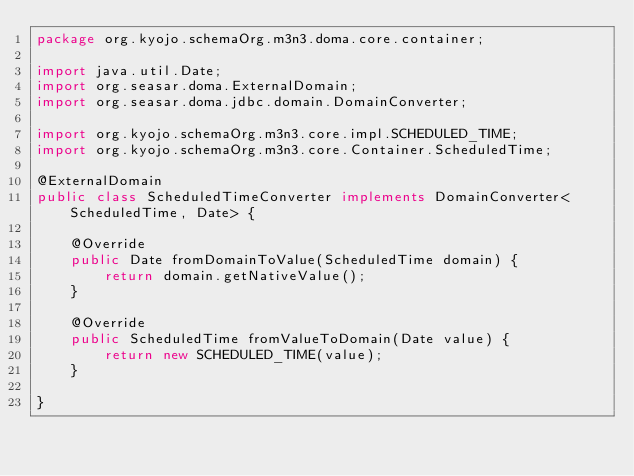Convert code to text. <code><loc_0><loc_0><loc_500><loc_500><_Java_>package org.kyojo.schemaOrg.m3n3.doma.core.container;

import java.util.Date;
import org.seasar.doma.ExternalDomain;
import org.seasar.doma.jdbc.domain.DomainConverter;

import org.kyojo.schemaOrg.m3n3.core.impl.SCHEDULED_TIME;
import org.kyojo.schemaOrg.m3n3.core.Container.ScheduledTime;

@ExternalDomain
public class ScheduledTimeConverter implements DomainConverter<ScheduledTime, Date> {

	@Override
	public Date fromDomainToValue(ScheduledTime domain) {
		return domain.getNativeValue();
	}

	@Override
	public ScheduledTime fromValueToDomain(Date value) {
		return new SCHEDULED_TIME(value);
	}

}
</code> 